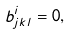Convert formula to latex. <formula><loc_0><loc_0><loc_500><loc_500>b _ { j k l } ^ { i } = 0 ,</formula> 